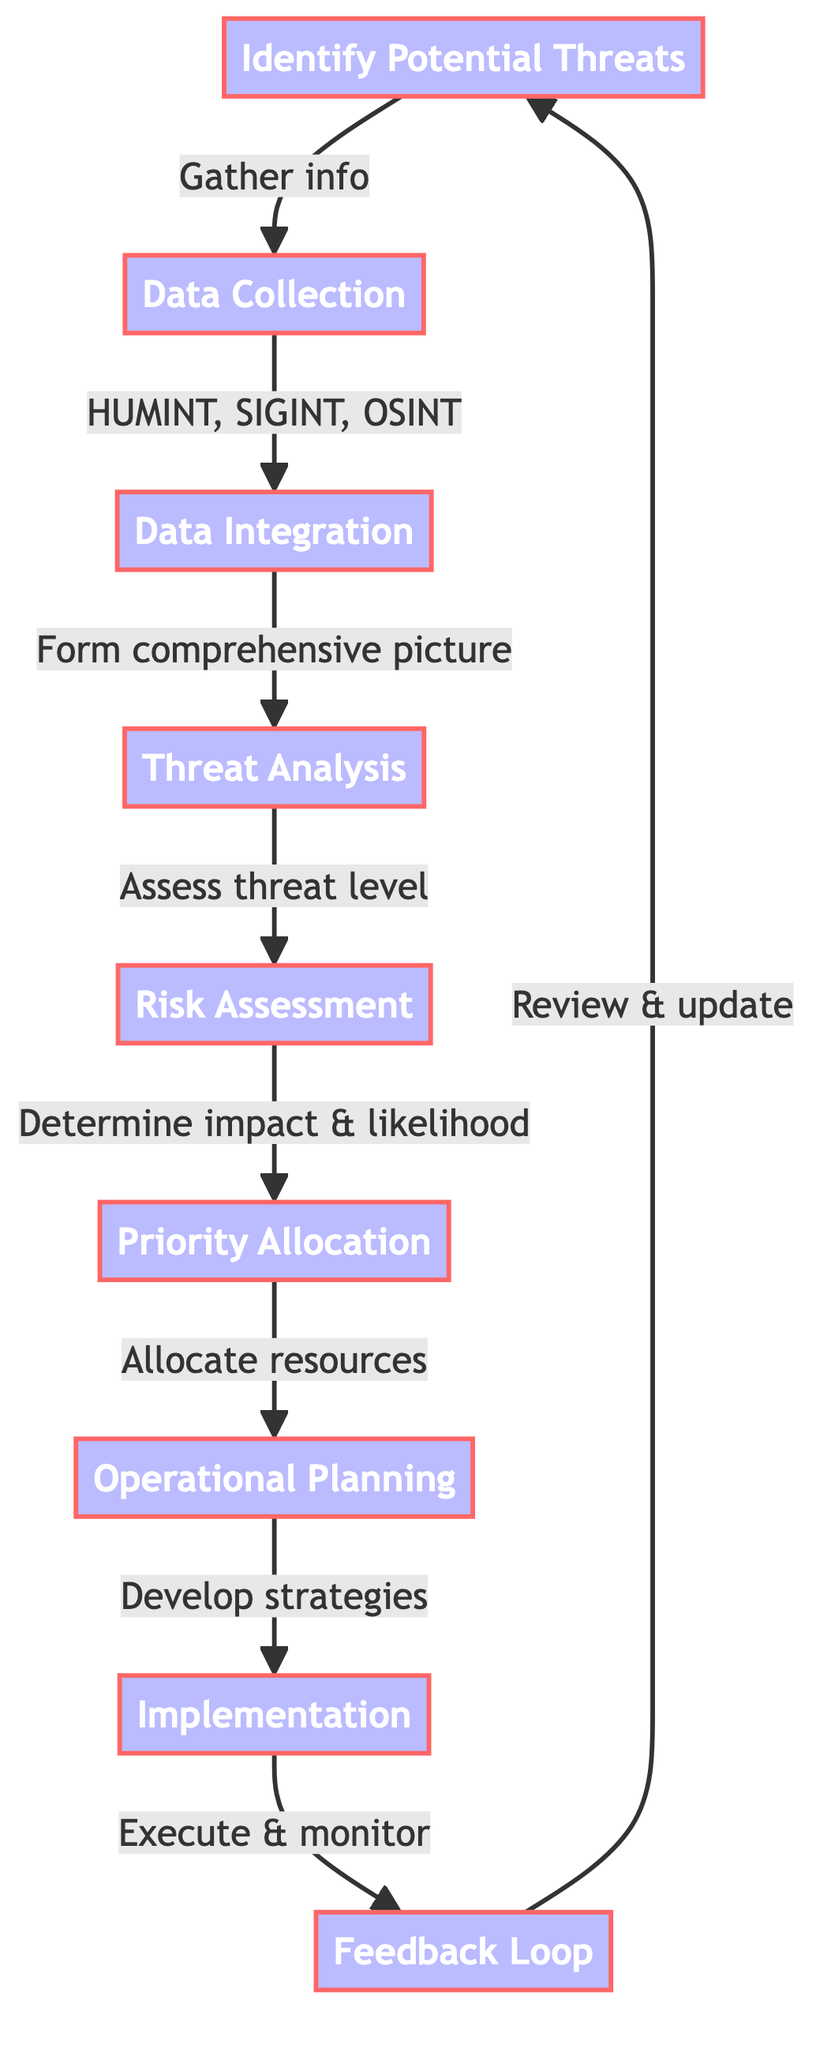What is the first step in the process? The flow chart starts with the node labeled "Identify Potential Threats," which is the first step in the threat assessment and risk management process.
Answer: Identify Potential Threats How many total steps are shown in the diagram? The diagram consists of nine distinct steps, labeled from 1 to 9.
Answer: 9 What follows after "Risk Assessment"? From the "Risk Assessment" step, the next step in the process is "Priority Allocation," which assesses the potential impact and likelihood of threats.
Answer: Priority Allocation What types of intelligence are collected during the "Data Collection" step? In the "Data Collection" step, three types of intelligence are gathered: human intelligence (HUMINT), signals intelligence (SIGINT), and open-source intelligence (OSINT).
Answer: HUMINT, SIGINT, OSINT What is the purpose of the "Feedback Loop"? The purpose of the "Feedback Loop" is to regularly review and update the procedures based on new intelligence and outcomes, ensuring continual improvement in the process.
Answer: Review and update What is assessed in the "Threat Analysis" step? In the "Threat Analysis" step, the level of threat posed by identified individuals or groups is assessed based on the integrated data collected earlier in the process.
Answer: Level of threat How do the steps connect from "Implementation" back to "Identify Potential Threats"? After "Implementation," the flow moves to the "Feedback Loop," which leads back to "Identify Potential Threats," indicating an ongoing cycle of assessment and response.
Answer: Feedback Loop What is determined in the "Risk Assessment" step? In the "Risk Assessment" step, decision-makers determine the potential impact and likelihood of identified threats materializing, which informs future actions.
Answer: Potential impact and likelihood What is developed in the "Operational Planning" stage? During "Operational Planning," strategies and operational plans are developed to mitigate the identified threats, prioritizing resources effectively.
Answer: Strategies and operational plans 